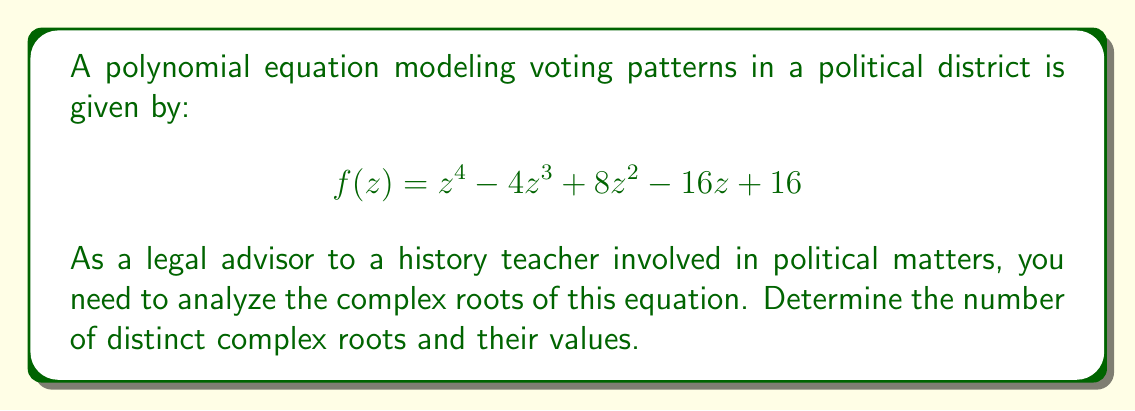Solve this math problem. To analyze the complex roots of this polynomial equation, we'll follow these steps:

1) First, observe that the polynomial can be factored as:

   $$f(z) = (z^2 - 2z + 4)^2$$

2) This is because $(z^2 - 2z + 4)^2 = z^4 - 4z^3 + 8z^2 - 16z + 16$

3) Now, we need to solve $z^2 - 2z + 4 = 0$

4) This is a quadratic equation. We can solve it using the quadratic formula:

   $$z = \frac{-b \pm \sqrt{b^2 - 4ac}}{2a}$$

   where $a=1$, $b=-2$, and $c=4$

5) Substituting these values:

   $$z = \frac{2 \pm \sqrt{4 - 16}}{2} = \frac{2 \pm \sqrt{-12}}{2} = \frac{2 \pm 2i\sqrt{3}}{2}$$

6) Simplifying:

   $$z = 1 \pm i\sqrt{3}$$

7) Therefore, the two complex roots are:

   $$z_1 = 1 + i\sqrt{3}$$ and $$z_2 = 1 - i\sqrt{3}$$

8) Since the original polynomial is $(z^2 - 2z + 4)^2$, each of these roots has a multiplicity of 2.

This analysis shows that the voting pattern model has two distinct complex roots, each with a multiplicity of 2. In the context of voting patterns, complex roots might indicate oscillatory or cyclical behavior in voting trends, which could be valuable information for a history teacher involved in political matters.
Answer: The polynomial has two distinct complex roots, each with a multiplicity of 2:

$$z_1 = 1 + i\sqrt{3}$$ and $$z_2 = 1 - i\sqrt{3}$$ 